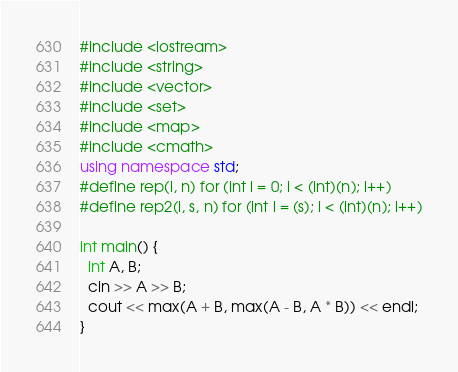<code> <loc_0><loc_0><loc_500><loc_500><_C++_>#include <iostream>
#include <string>
#include <vector>
#include <set>
#include <map>
#include <cmath>
using namespace std;
#define rep(i, n) for (int i = 0; i < (int)(n); i++)
#define rep2(i, s, n) for (int i = (s); i < (int)(n); i++)

int main() {
  int A, B;
  cin >> A >> B;
  cout << max(A + B, max(A - B, A * B)) << endl;
}
</code> 